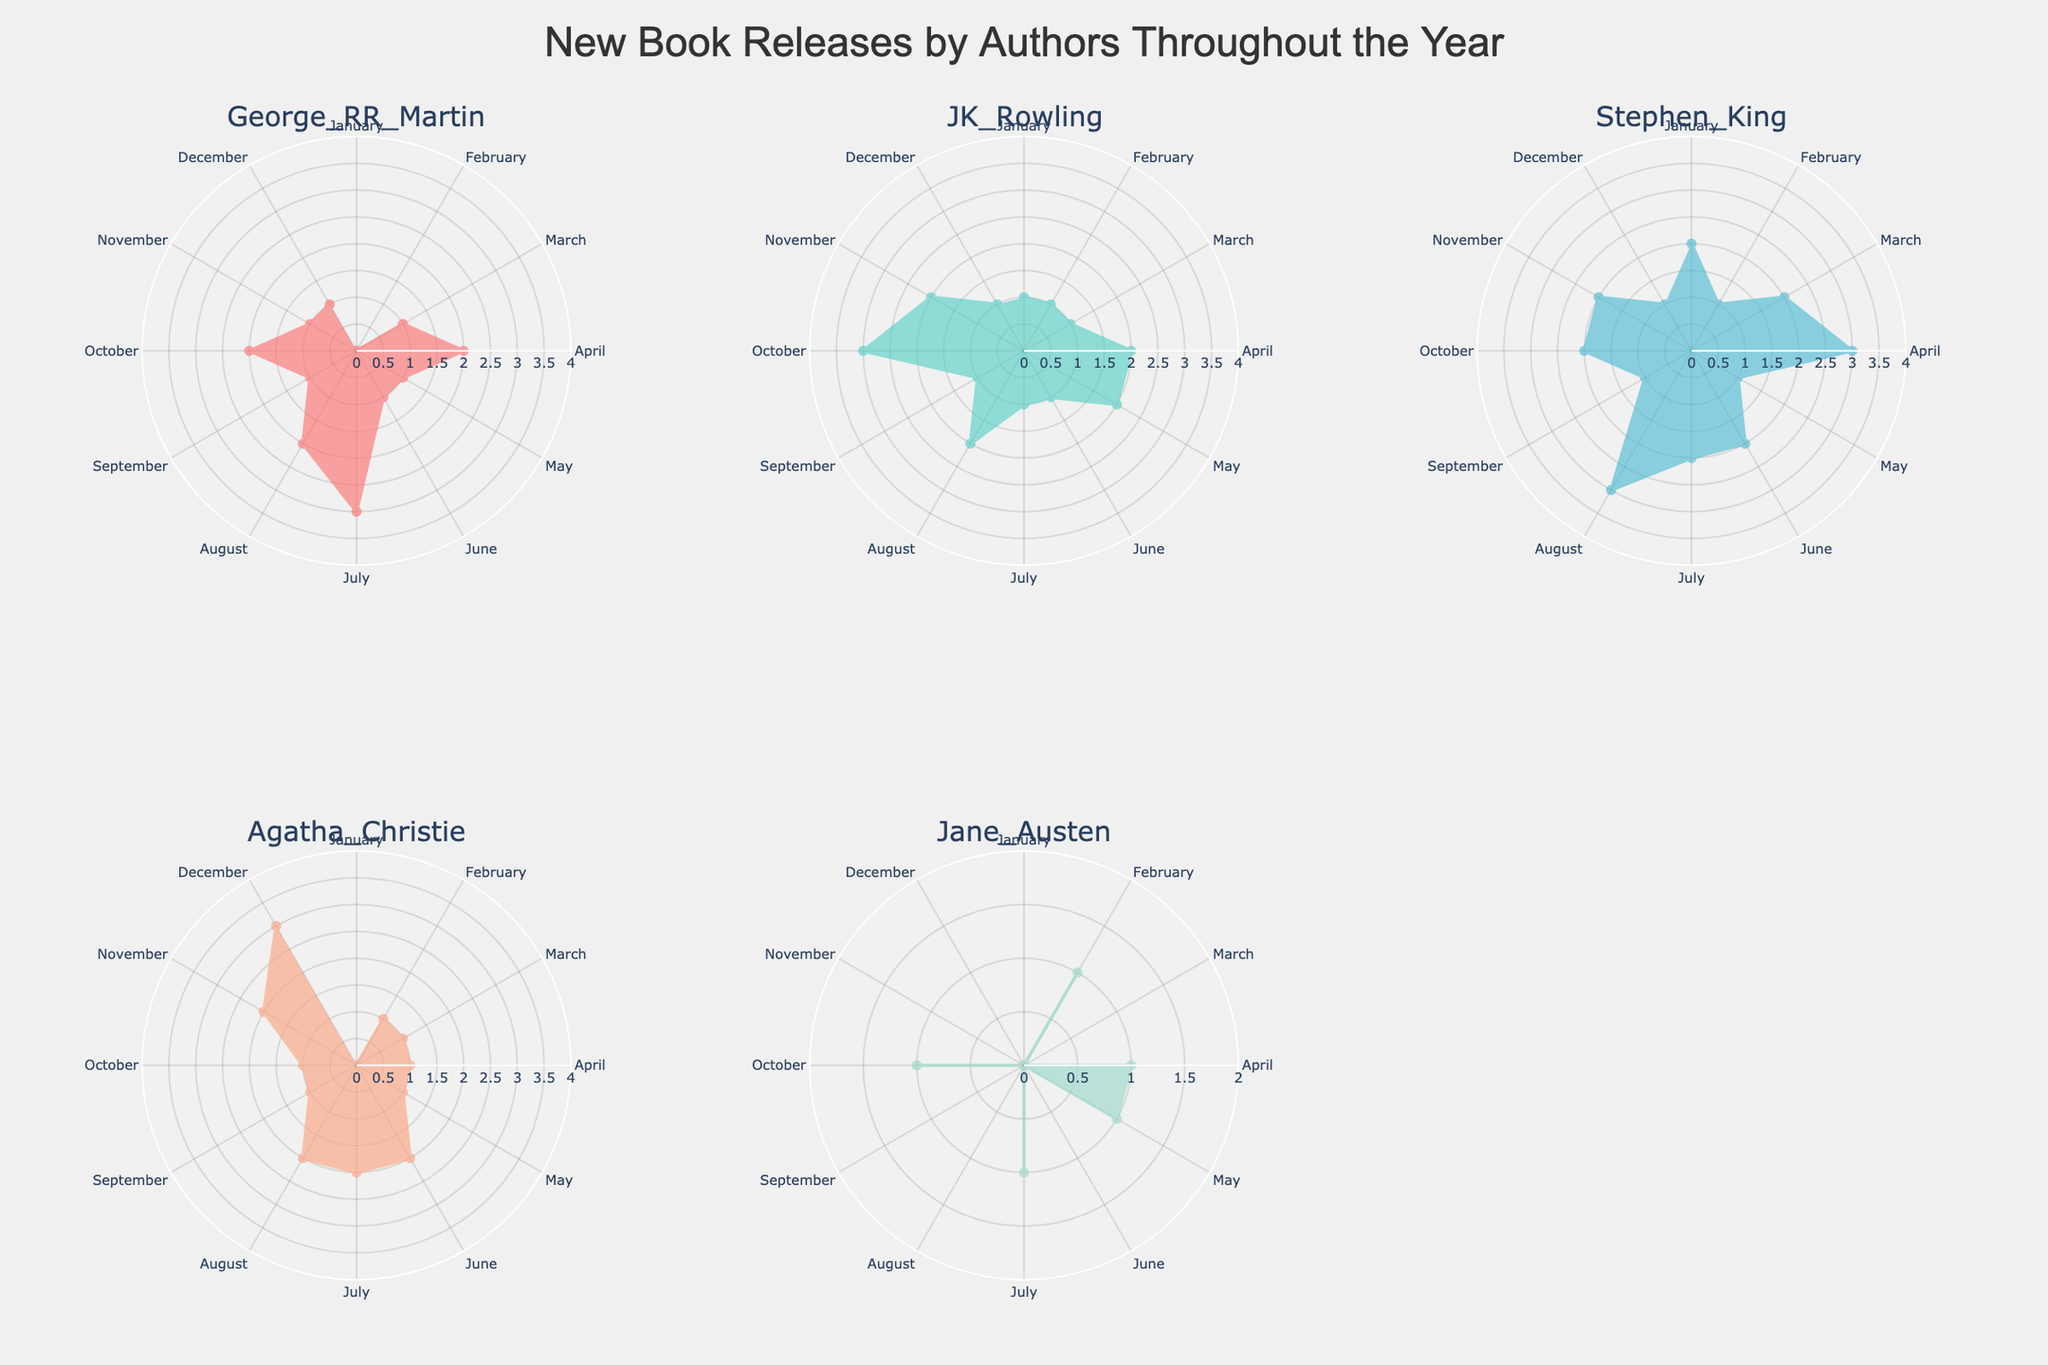What is the title of the figure? The figure includes a title which is given at the top center of the chart.
Answer: New Book Releases by Authors Throughout the Year Which author has the highest number of book releases in July? To determine this, look at the subplot for each author and find the value corresponding to July in each polar chart. George R.R. Martin has the highest value.
Answer: George R.R. Martin What is the total number of books released by Jane Austen in the first quarter of the year? The first quarter of the year includes January, February, and March. Adding the number of releases for Jane Austen in these months gives 0 + 1 + 0 = 1.
Answer: 1 How many books did Stephen King release in October compared to August? Find the values for Stephen King in October and August in his respective subplot. The values are 2 and 3, respectively. So, in August, he released one more book than in October.
Answer: One more book in August Which month has the highest total number of book releases across all authors? To find this, sum the number of book releases by all authors for each month. April has the highest total, with 2 + 2 + 3 + 1 + 1 = 9.
Answer: April What is the average number of book releases by Agatha Christie over the year? Sum the number of book releases by Agatha Christie for each month and then divide by 12 (the number of months). The sum is 0 + 1 + 1 + 1 + 1 + 2 + 2 + 2 + 1 + 1 + 2 + 3 = 17. The average is 17 / 12 ≈ 1.42.
Answer: 1.42 Compare the number of book releases by J.K. Rowling and George R.R. Martin in December. Who released more? Looking at the subplots for J.K. Rowling and George R.R. Martin, in December, J.K. Rowling released 1 book, and George R.R. Martin released 1 book. Hence, they released the same number.
Answer: Same number What is the difference in the number of books released by Stephen King in June and November? Check the subplots for Stephen King and find the values for June and November. In June, he released 2 books, and in November, he released 2 books. The difference is 2 - 2 = 0.
Answer: 0 Which month had the least number of book releases for Agatha Christie? Examine Agatha Christie's subplot and find the month with the lowest value. The month with the lowest value appears to be January with 0 releases.
Answer: January 